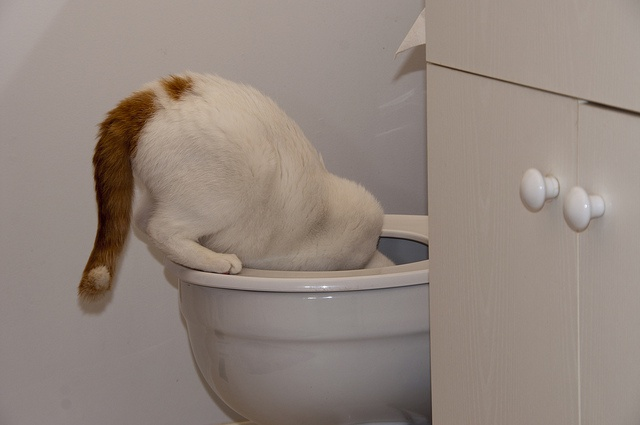Describe the objects in this image and their specific colors. I can see cat in darkgray and gray tones and toilet in darkgray and gray tones in this image. 